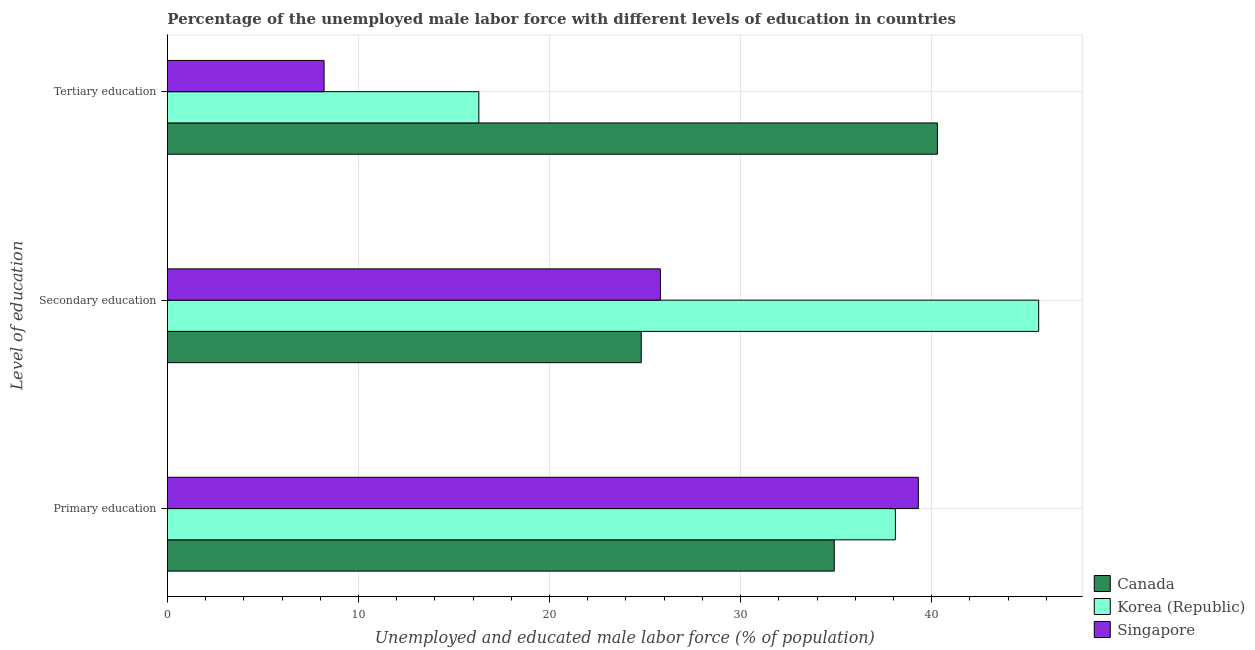How many bars are there on the 2nd tick from the top?
Ensure brevity in your answer.  3. What is the label of the 2nd group of bars from the top?
Your response must be concise. Secondary education. What is the percentage of male labor force who received primary education in Singapore?
Give a very brief answer. 39.3. Across all countries, what is the maximum percentage of male labor force who received primary education?
Your answer should be very brief. 39.3. Across all countries, what is the minimum percentage of male labor force who received primary education?
Your answer should be compact. 34.9. In which country was the percentage of male labor force who received primary education maximum?
Your answer should be compact. Singapore. What is the total percentage of male labor force who received primary education in the graph?
Provide a succinct answer. 112.3. What is the difference between the percentage of male labor force who received secondary education in Canada and that in Korea (Republic)?
Keep it short and to the point. -20.8. What is the difference between the percentage of male labor force who received secondary education in Korea (Republic) and the percentage of male labor force who received tertiary education in Canada?
Make the answer very short. 5.3. What is the average percentage of male labor force who received primary education per country?
Offer a terse response. 37.43. What is the difference between the percentage of male labor force who received secondary education and percentage of male labor force who received primary education in Canada?
Keep it short and to the point. -10.1. In how many countries, is the percentage of male labor force who received primary education greater than 2 %?
Provide a short and direct response. 3. What is the ratio of the percentage of male labor force who received tertiary education in Canada to that in Singapore?
Ensure brevity in your answer.  4.91. What is the difference between the highest and the second highest percentage of male labor force who received tertiary education?
Ensure brevity in your answer.  24. What is the difference between the highest and the lowest percentage of male labor force who received primary education?
Offer a very short reply. 4.4. In how many countries, is the percentage of male labor force who received secondary education greater than the average percentage of male labor force who received secondary education taken over all countries?
Provide a succinct answer. 1. Is the sum of the percentage of male labor force who received secondary education in Singapore and Korea (Republic) greater than the maximum percentage of male labor force who received primary education across all countries?
Offer a very short reply. Yes. What does the 3rd bar from the top in Primary education represents?
Provide a short and direct response. Canada. What does the 3rd bar from the bottom in Secondary education represents?
Your answer should be compact. Singapore. Where does the legend appear in the graph?
Make the answer very short. Bottom right. How many legend labels are there?
Your answer should be very brief. 3. How are the legend labels stacked?
Your answer should be very brief. Vertical. What is the title of the graph?
Your response must be concise. Percentage of the unemployed male labor force with different levels of education in countries. What is the label or title of the X-axis?
Offer a very short reply. Unemployed and educated male labor force (% of population). What is the label or title of the Y-axis?
Provide a succinct answer. Level of education. What is the Unemployed and educated male labor force (% of population) in Canada in Primary education?
Provide a succinct answer. 34.9. What is the Unemployed and educated male labor force (% of population) of Korea (Republic) in Primary education?
Ensure brevity in your answer.  38.1. What is the Unemployed and educated male labor force (% of population) in Singapore in Primary education?
Provide a succinct answer. 39.3. What is the Unemployed and educated male labor force (% of population) of Canada in Secondary education?
Offer a very short reply. 24.8. What is the Unemployed and educated male labor force (% of population) in Korea (Republic) in Secondary education?
Provide a succinct answer. 45.6. What is the Unemployed and educated male labor force (% of population) in Singapore in Secondary education?
Make the answer very short. 25.8. What is the Unemployed and educated male labor force (% of population) in Canada in Tertiary education?
Provide a succinct answer. 40.3. What is the Unemployed and educated male labor force (% of population) of Korea (Republic) in Tertiary education?
Provide a short and direct response. 16.3. What is the Unemployed and educated male labor force (% of population) of Singapore in Tertiary education?
Your answer should be very brief. 8.2. Across all Level of education, what is the maximum Unemployed and educated male labor force (% of population) in Canada?
Your answer should be very brief. 40.3. Across all Level of education, what is the maximum Unemployed and educated male labor force (% of population) in Korea (Republic)?
Make the answer very short. 45.6. Across all Level of education, what is the maximum Unemployed and educated male labor force (% of population) of Singapore?
Ensure brevity in your answer.  39.3. Across all Level of education, what is the minimum Unemployed and educated male labor force (% of population) in Canada?
Ensure brevity in your answer.  24.8. Across all Level of education, what is the minimum Unemployed and educated male labor force (% of population) in Korea (Republic)?
Ensure brevity in your answer.  16.3. Across all Level of education, what is the minimum Unemployed and educated male labor force (% of population) of Singapore?
Your response must be concise. 8.2. What is the total Unemployed and educated male labor force (% of population) of Canada in the graph?
Keep it short and to the point. 100. What is the total Unemployed and educated male labor force (% of population) in Korea (Republic) in the graph?
Offer a terse response. 100. What is the total Unemployed and educated male labor force (% of population) in Singapore in the graph?
Offer a very short reply. 73.3. What is the difference between the Unemployed and educated male labor force (% of population) in Canada in Primary education and that in Secondary education?
Give a very brief answer. 10.1. What is the difference between the Unemployed and educated male labor force (% of population) of Korea (Republic) in Primary education and that in Secondary education?
Make the answer very short. -7.5. What is the difference between the Unemployed and educated male labor force (% of population) of Canada in Primary education and that in Tertiary education?
Keep it short and to the point. -5.4. What is the difference between the Unemployed and educated male labor force (% of population) of Korea (Republic) in Primary education and that in Tertiary education?
Keep it short and to the point. 21.8. What is the difference between the Unemployed and educated male labor force (% of population) of Singapore in Primary education and that in Tertiary education?
Provide a short and direct response. 31.1. What is the difference between the Unemployed and educated male labor force (% of population) of Canada in Secondary education and that in Tertiary education?
Provide a succinct answer. -15.5. What is the difference between the Unemployed and educated male labor force (% of population) of Korea (Republic) in Secondary education and that in Tertiary education?
Offer a very short reply. 29.3. What is the difference between the Unemployed and educated male labor force (% of population) in Canada in Primary education and the Unemployed and educated male labor force (% of population) in Korea (Republic) in Tertiary education?
Ensure brevity in your answer.  18.6. What is the difference between the Unemployed and educated male labor force (% of population) in Canada in Primary education and the Unemployed and educated male labor force (% of population) in Singapore in Tertiary education?
Keep it short and to the point. 26.7. What is the difference between the Unemployed and educated male labor force (% of population) in Korea (Republic) in Primary education and the Unemployed and educated male labor force (% of population) in Singapore in Tertiary education?
Make the answer very short. 29.9. What is the difference between the Unemployed and educated male labor force (% of population) in Canada in Secondary education and the Unemployed and educated male labor force (% of population) in Korea (Republic) in Tertiary education?
Keep it short and to the point. 8.5. What is the difference between the Unemployed and educated male labor force (% of population) of Canada in Secondary education and the Unemployed and educated male labor force (% of population) of Singapore in Tertiary education?
Provide a short and direct response. 16.6. What is the difference between the Unemployed and educated male labor force (% of population) in Korea (Republic) in Secondary education and the Unemployed and educated male labor force (% of population) in Singapore in Tertiary education?
Keep it short and to the point. 37.4. What is the average Unemployed and educated male labor force (% of population) of Canada per Level of education?
Give a very brief answer. 33.33. What is the average Unemployed and educated male labor force (% of population) in Korea (Republic) per Level of education?
Keep it short and to the point. 33.33. What is the average Unemployed and educated male labor force (% of population) in Singapore per Level of education?
Your answer should be compact. 24.43. What is the difference between the Unemployed and educated male labor force (% of population) of Canada and Unemployed and educated male labor force (% of population) of Korea (Republic) in Primary education?
Ensure brevity in your answer.  -3.2. What is the difference between the Unemployed and educated male labor force (% of population) of Korea (Republic) and Unemployed and educated male labor force (% of population) of Singapore in Primary education?
Offer a terse response. -1.2. What is the difference between the Unemployed and educated male labor force (% of population) of Canada and Unemployed and educated male labor force (% of population) of Korea (Republic) in Secondary education?
Provide a succinct answer. -20.8. What is the difference between the Unemployed and educated male labor force (% of population) in Canada and Unemployed and educated male labor force (% of population) in Singapore in Secondary education?
Provide a succinct answer. -1. What is the difference between the Unemployed and educated male labor force (% of population) in Korea (Republic) and Unemployed and educated male labor force (% of population) in Singapore in Secondary education?
Give a very brief answer. 19.8. What is the difference between the Unemployed and educated male labor force (% of population) in Canada and Unemployed and educated male labor force (% of population) in Singapore in Tertiary education?
Your response must be concise. 32.1. What is the difference between the Unemployed and educated male labor force (% of population) in Korea (Republic) and Unemployed and educated male labor force (% of population) in Singapore in Tertiary education?
Provide a short and direct response. 8.1. What is the ratio of the Unemployed and educated male labor force (% of population) in Canada in Primary education to that in Secondary education?
Provide a short and direct response. 1.41. What is the ratio of the Unemployed and educated male labor force (% of population) of Korea (Republic) in Primary education to that in Secondary education?
Ensure brevity in your answer.  0.84. What is the ratio of the Unemployed and educated male labor force (% of population) in Singapore in Primary education to that in Secondary education?
Your response must be concise. 1.52. What is the ratio of the Unemployed and educated male labor force (% of population) of Canada in Primary education to that in Tertiary education?
Provide a short and direct response. 0.87. What is the ratio of the Unemployed and educated male labor force (% of population) of Korea (Republic) in Primary education to that in Tertiary education?
Keep it short and to the point. 2.34. What is the ratio of the Unemployed and educated male labor force (% of population) of Singapore in Primary education to that in Tertiary education?
Offer a very short reply. 4.79. What is the ratio of the Unemployed and educated male labor force (% of population) of Canada in Secondary education to that in Tertiary education?
Offer a terse response. 0.62. What is the ratio of the Unemployed and educated male labor force (% of population) in Korea (Republic) in Secondary education to that in Tertiary education?
Provide a short and direct response. 2.8. What is the ratio of the Unemployed and educated male labor force (% of population) in Singapore in Secondary education to that in Tertiary education?
Make the answer very short. 3.15. What is the difference between the highest and the second highest Unemployed and educated male labor force (% of population) of Canada?
Provide a succinct answer. 5.4. What is the difference between the highest and the second highest Unemployed and educated male labor force (% of population) in Korea (Republic)?
Provide a short and direct response. 7.5. What is the difference between the highest and the lowest Unemployed and educated male labor force (% of population) in Canada?
Provide a short and direct response. 15.5. What is the difference between the highest and the lowest Unemployed and educated male labor force (% of population) of Korea (Republic)?
Your response must be concise. 29.3. What is the difference between the highest and the lowest Unemployed and educated male labor force (% of population) in Singapore?
Ensure brevity in your answer.  31.1. 